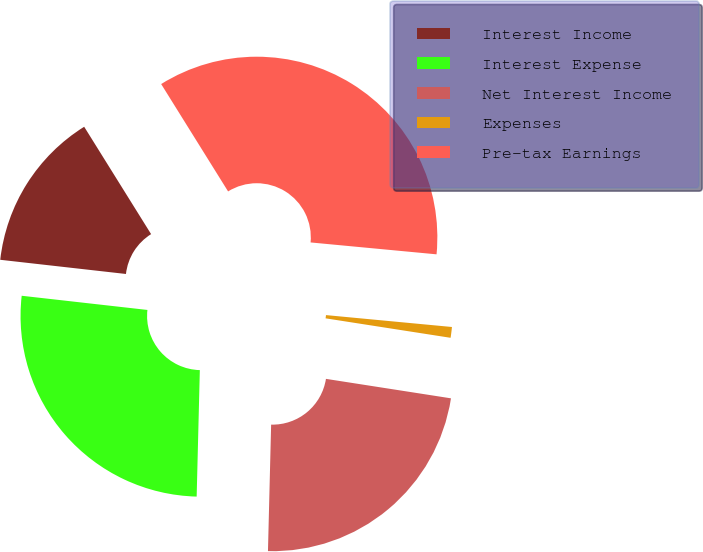Convert chart to OTSL. <chart><loc_0><loc_0><loc_500><loc_500><pie_chart><fcel>Interest Income<fcel>Interest Expense<fcel>Net Interest Income<fcel>Expenses<fcel>Pre-tax Earnings<nl><fcel>14.34%<fcel>26.39%<fcel>22.94%<fcel>0.96%<fcel>35.37%<nl></chart> 